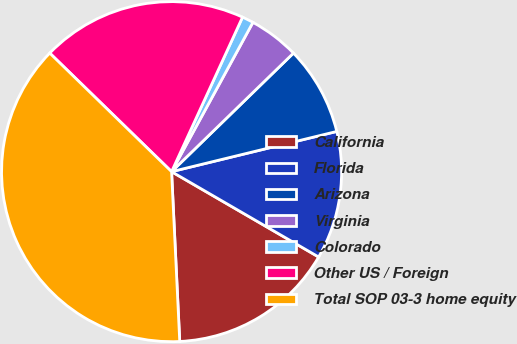<chart> <loc_0><loc_0><loc_500><loc_500><pie_chart><fcel>California<fcel>Florida<fcel>Arizona<fcel>Virginia<fcel>Colorado<fcel>Other US / Foreign<fcel>Total SOP 03-3 home equity<nl><fcel>15.87%<fcel>12.17%<fcel>8.48%<fcel>4.78%<fcel>1.09%<fcel>19.57%<fcel>38.05%<nl></chart> 